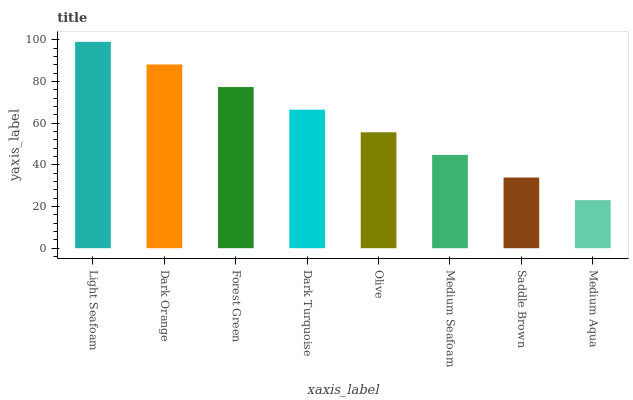Is Dark Orange the minimum?
Answer yes or no. No. Is Dark Orange the maximum?
Answer yes or no. No. Is Light Seafoam greater than Dark Orange?
Answer yes or no. Yes. Is Dark Orange less than Light Seafoam?
Answer yes or no. Yes. Is Dark Orange greater than Light Seafoam?
Answer yes or no. No. Is Light Seafoam less than Dark Orange?
Answer yes or no. No. Is Dark Turquoise the high median?
Answer yes or no. Yes. Is Olive the low median?
Answer yes or no. Yes. Is Medium Aqua the high median?
Answer yes or no. No. Is Dark Orange the low median?
Answer yes or no. No. 